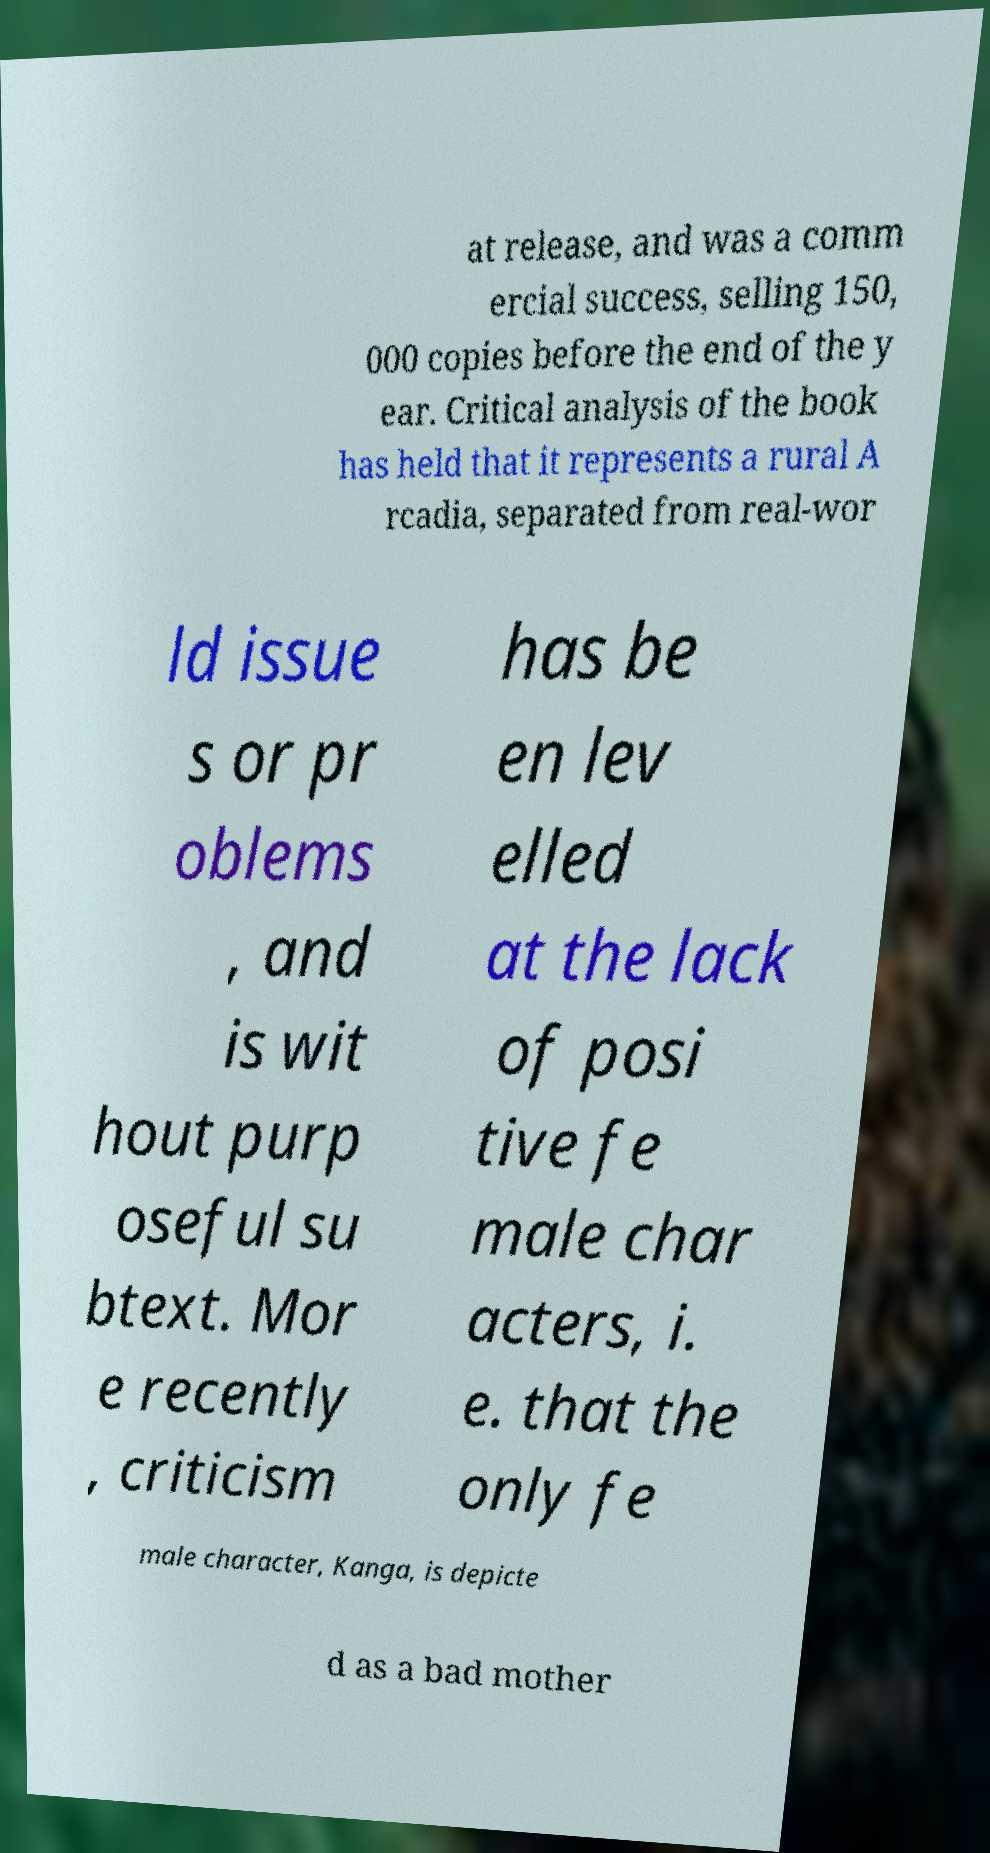Could you assist in decoding the text presented in this image and type it out clearly? at release, and was a comm ercial success, selling 150, 000 copies before the end of the y ear. Critical analysis of the book has held that it represents a rural A rcadia, separated from real-wor ld issue s or pr oblems , and is wit hout purp oseful su btext. Mor e recently , criticism has be en lev elled at the lack of posi tive fe male char acters, i. e. that the only fe male character, Kanga, is depicte d as a bad mother 